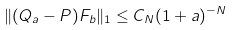<formula> <loc_0><loc_0><loc_500><loc_500>\| ( Q _ { a } - P ) F _ { b } \| _ { 1 } \leq C _ { N } ( 1 + a ) ^ { - N }</formula> 